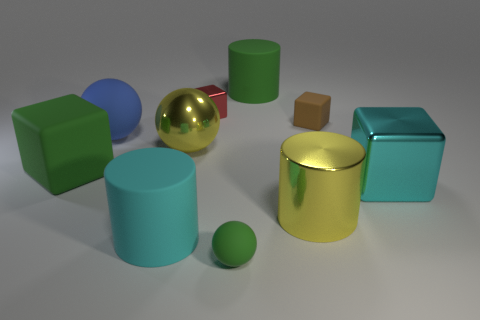Are there any other things of the same color as the small rubber sphere?
Ensure brevity in your answer.  Yes. What size is the yellow object in front of the large yellow sphere?
Give a very brief answer. Large. There is a large metallic ball; is its color the same as the large cube that is on the right side of the tiny red thing?
Keep it short and to the point. No. How many other things are the same material as the tiny brown thing?
Make the answer very short. 5. Are there more large gray objects than yellow cylinders?
Ensure brevity in your answer.  No. There is a cylinder that is right of the green cylinder; is its color the same as the small rubber block?
Your answer should be compact. No. What color is the tiny metal thing?
Your answer should be very brief. Red. There is a small thing that is on the right side of the large green cylinder; are there any tiny brown cubes that are behind it?
Offer a terse response. No. There is a big yellow thing that is on the right side of the tiny thing to the left of the green rubber ball; what is its shape?
Provide a short and direct response. Cylinder. Are there fewer green blocks than yellow things?
Provide a short and direct response. Yes. 